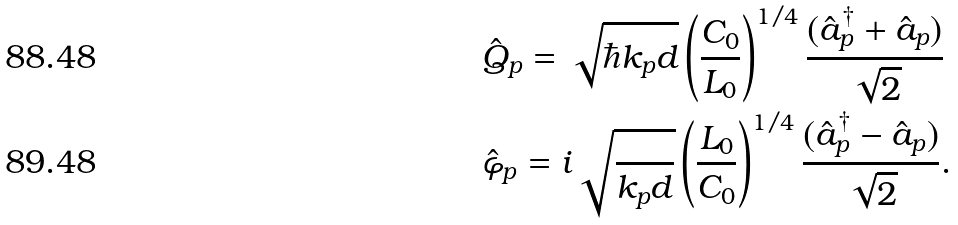Convert formula to latex. <formula><loc_0><loc_0><loc_500><loc_500>& \hat { Q } _ { p } = \sqrt { \hbar { k } _ { p } d } \left ( \frac { C _ { 0 } } { L _ { 0 } } \right ) ^ { 1 / 4 } \frac { ( \hat { a } _ { p } ^ { \dag } + \hat { a } _ { p } ) } { \sqrt { 2 } } \\ & \hat { \varphi } _ { p } = i \sqrt { \frac { } { k _ { p } d } } \left ( \frac { L _ { 0 } } { C _ { 0 } } \right ) ^ { 1 / 4 } \frac { ( \hat { a } _ { p } ^ { \dag } - \hat { a } _ { p } ) } { \sqrt { 2 } } .</formula> 